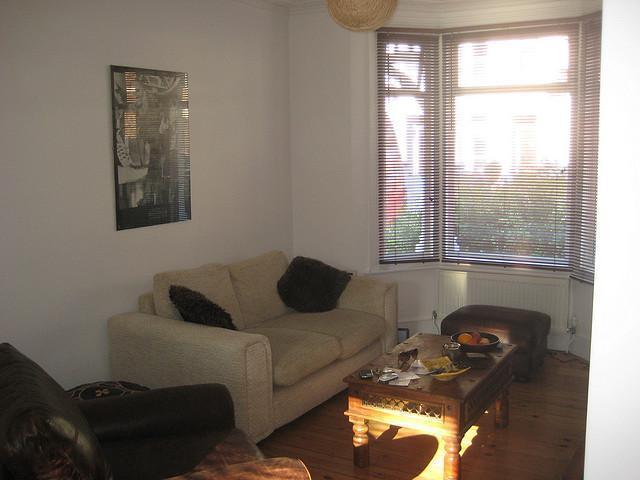What is on the wall?
Select the accurate response from the four choices given to answer the question.
Options: Statue, cat, fly, picture. Picture. 